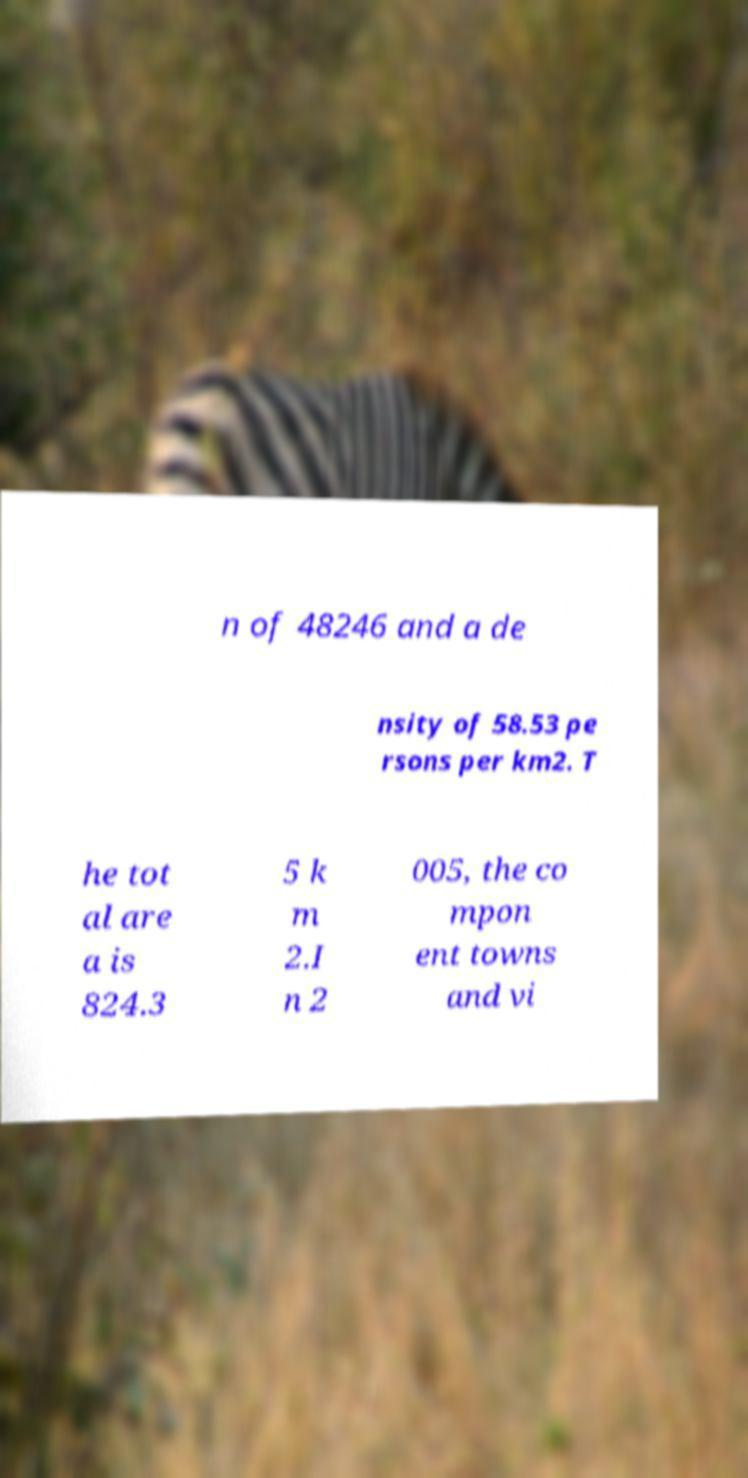Can you accurately transcribe the text from the provided image for me? n of 48246 and a de nsity of 58.53 pe rsons per km2. T he tot al are a is 824.3 5 k m 2.I n 2 005, the co mpon ent towns and vi 